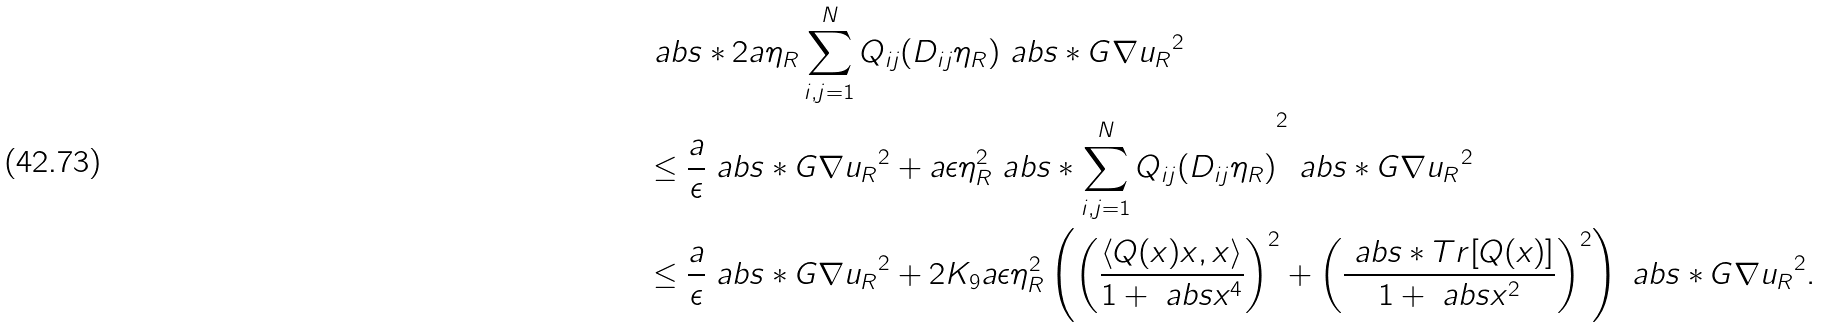<formula> <loc_0><loc_0><loc_500><loc_500>& \ a b s * { 2 a \eta _ { R } \sum _ { i , j = 1 } ^ { N } Q _ { i j } ( D _ { i j } \eta _ { R } ) \ a b s * { G \nabla u _ { R } } ^ { 2 } } \\ & \leq \frac { a } { \epsilon } \ a b s * { G \nabla u _ { R } } ^ { 2 } + a \epsilon \eta _ { R } ^ { 2 } \ a b s * { \sum _ { i , j = 1 } ^ { N } Q _ { i j } ( D _ { i j } \eta _ { R } ) } ^ { 2 } \ a b s * { G \nabla u _ { R } } ^ { 2 } \\ & \leq \frac { a } { \epsilon } \ a b s * { G \nabla u _ { R } } ^ { 2 } + 2 K _ { 9 } a \epsilon \eta _ { R } ^ { 2 } \left ( \left ( \frac { \langle Q ( x ) x , x \rangle } { 1 + \ a b s x ^ { 4 } } \right ) ^ { 2 } + \left ( \frac { \ a b s * { T r [ Q ( x ) ] } } { 1 + \ a b s x ^ { 2 } } \right ) ^ { 2 } \right ) \ a b s * { G \nabla u _ { R } } ^ { 2 } .</formula> 